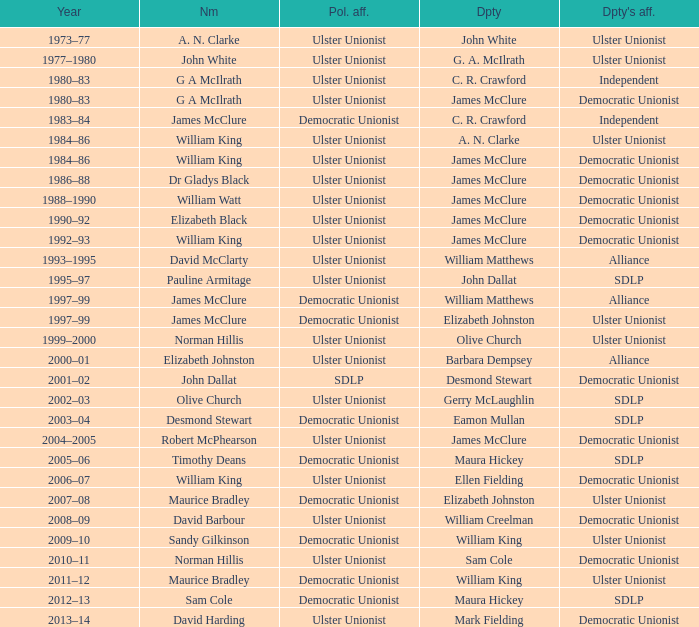What is the Name for 1997–99? James McClure, James McClure. Could you help me parse every detail presented in this table? {'header': ['Year', 'Nm', 'Pol. aff.', 'Dpty', "Dpty's aff."], 'rows': [['1973–77', 'A. N. Clarke', 'Ulster Unionist', 'John White', 'Ulster Unionist'], ['1977–1980', 'John White', 'Ulster Unionist', 'G. A. McIlrath', 'Ulster Unionist'], ['1980–83', 'G A McIlrath', 'Ulster Unionist', 'C. R. Crawford', 'Independent'], ['1980–83', 'G A McIlrath', 'Ulster Unionist', 'James McClure', 'Democratic Unionist'], ['1983–84', 'James McClure', 'Democratic Unionist', 'C. R. Crawford', 'Independent'], ['1984–86', 'William King', 'Ulster Unionist', 'A. N. Clarke', 'Ulster Unionist'], ['1984–86', 'William King', 'Ulster Unionist', 'James McClure', 'Democratic Unionist'], ['1986–88', 'Dr Gladys Black', 'Ulster Unionist', 'James McClure', 'Democratic Unionist'], ['1988–1990', 'William Watt', 'Ulster Unionist', 'James McClure', 'Democratic Unionist'], ['1990–92', 'Elizabeth Black', 'Ulster Unionist', 'James McClure', 'Democratic Unionist'], ['1992–93', 'William King', 'Ulster Unionist', 'James McClure', 'Democratic Unionist'], ['1993–1995', 'David McClarty', 'Ulster Unionist', 'William Matthews', 'Alliance'], ['1995–97', 'Pauline Armitage', 'Ulster Unionist', 'John Dallat', 'SDLP'], ['1997–99', 'James McClure', 'Democratic Unionist', 'William Matthews', 'Alliance'], ['1997–99', 'James McClure', 'Democratic Unionist', 'Elizabeth Johnston', 'Ulster Unionist'], ['1999–2000', 'Norman Hillis', 'Ulster Unionist', 'Olive Church', 'Ulster Unionist'], ['2000–01', 'Elizabeth Johnston', 'Ulster Unionist', 'Barbara Dempsey', 'Alliance'], ['2001–02', 'John Dallat', 'SDLP', 'Desmond Stewart', 'Democratic Unionist'], ['2002–03', 'Olive Church', 'Ulster Unionist', 'Gerry McLaughlin', 'SDLP'], ['2003–04', 'Desmond Stewart', 'Democratic Unionist', 'Eamon Mullan', 'SDLP'], ['2004–2005', 'Robert McPhearson', 'Ulster Unionist', 'James McClure', 'Democratic Unionist'], ['2005–06', 'Timothy Deans', 'Democratic Unionist', 'Maura Hickey', 'SDLP'], ['2006–07', 'William King', 'Ulster Unionist', 'Ellen Fielding', 'Democratic Unionist'], ['2007–08', 'Maurice Bradley', 'Democratic Unionist', 'Elizabeth Johnston', 'Ulster Unionist'], ['2008–09', 'David Barbour', 'Ulster Unionist', 'William Creelman', 'Democratic Unionist'], ['2009–10', 'Sandy Gilkinson', 'Democratic Unionist', 'William King', 'Ulster Unionist'], ['2010–11', 'Norman Hillis', 'Ulster Unionist', 'Sam Cole', 'Democratic Unionist'], ['2011–12', 'Maurice Bradley', 'Democratic Unionist', 'William King', 'Ulster Unionist'], ['2012–13', 'Sam Cole', 'Democratic Unionist', 'Maura Hickey', 'SDLP'], ['2013–14', 'David Harding', 'Ulster Unionist', 'Mark Fielding', 'Democratic Unionist']]} 